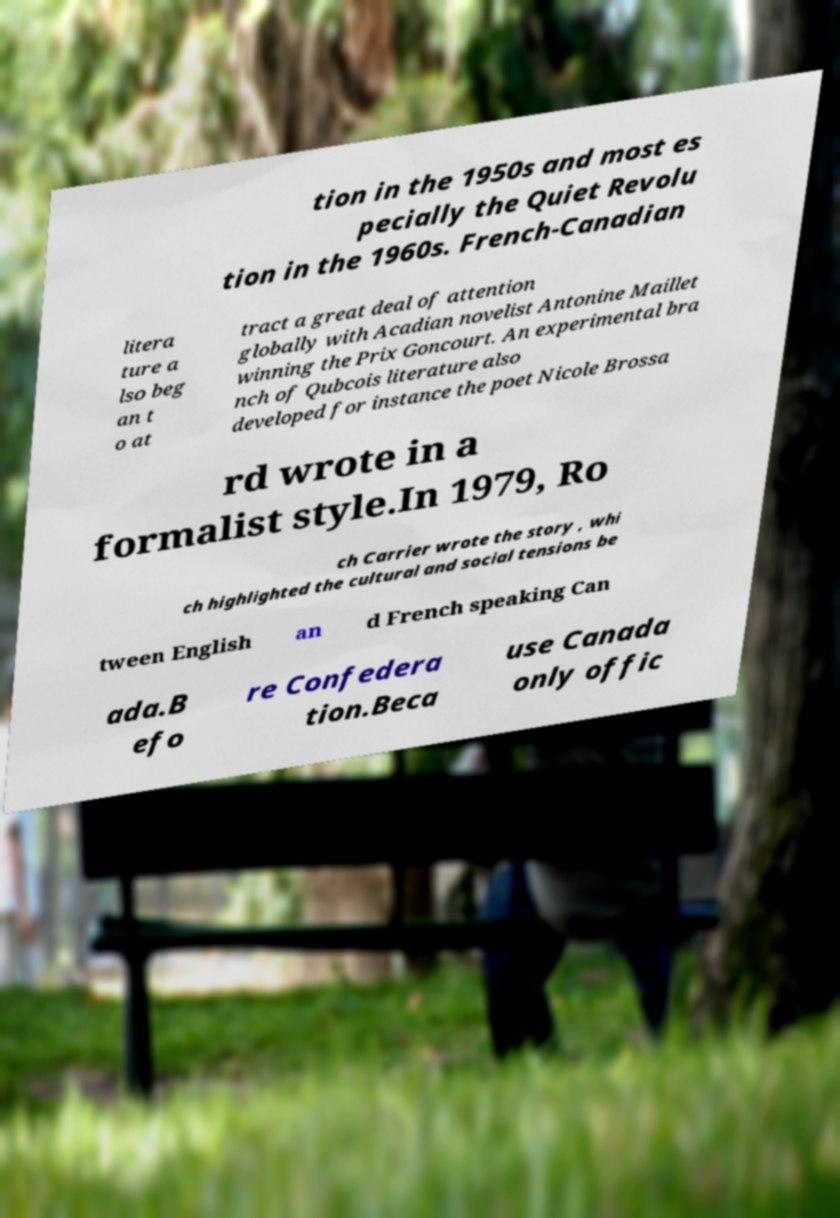I need the written content from this picture converted into text. Can you do that? tion in the 1950s and most es pecially the Quiet Revolu tion in the 1960s. French-Canadian litera ture a lso beg an t o at tract a great deal of attention globally with Acadian novelist Antonine Maillet winning the Prix Goncourt. An experimental bra nch of Qubcois literature also developed for instance the poet Nicole Brossa rd wrote in a formalist style.In 1979, Ro ch Carrier wrote the story , whi ch highlighted the cultural and social tensions be tween English an d French speaking Can ada.B efo re Confedera tion.Beca use Canada only offic 